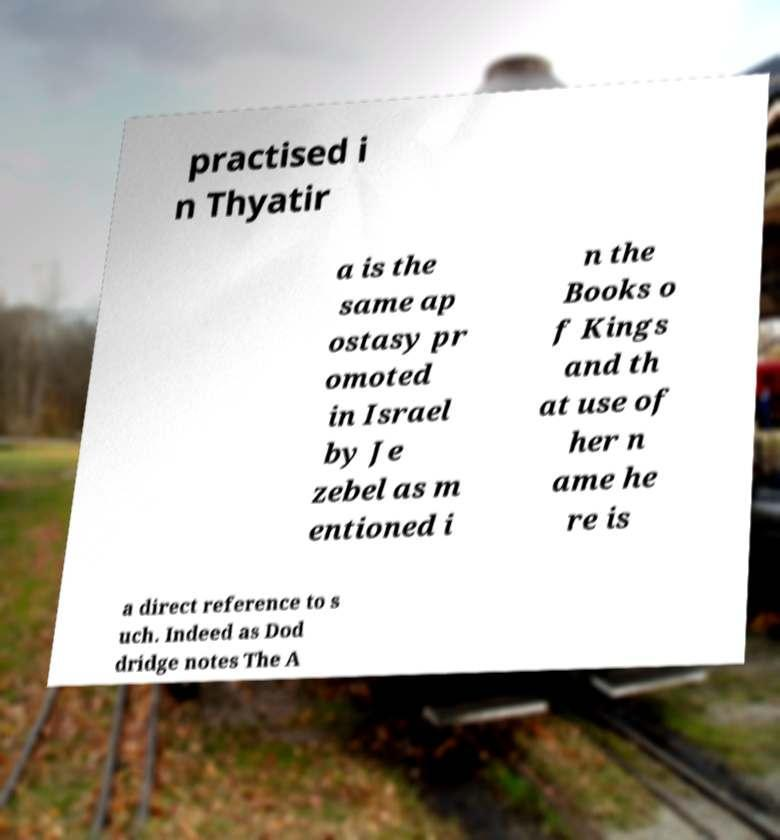There's text embedded in this image that I need extracted. Can you transcribe it verbatim? practised i n Thyatir a is the same ap ostasy pr omoted in Israel by Je zebel as m entioned i n the Books o f Kings and th at use of her n ame he re is a direct reference to s uch. Indeed as Dod dridge notes The A 